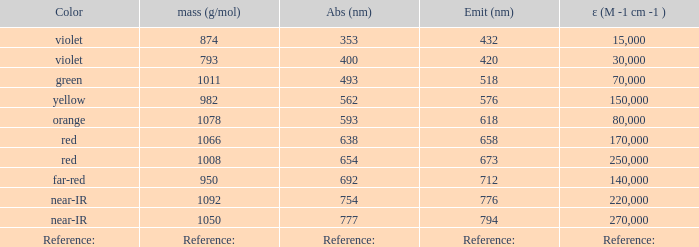What is the Absorbtion (in nanometers) of the color Orange? 593.0. 